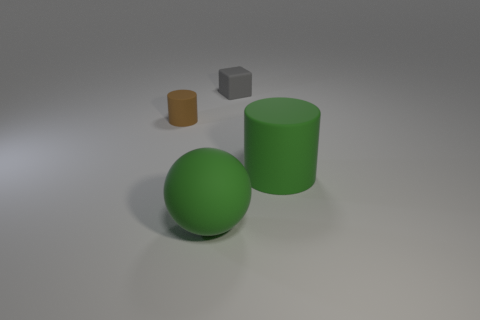What number of small brown rubber cylinders are in front of the large green object left of the small rubber object that is behind the small cylinder?
Offer a terse response. 0. There is a big green rubber sphere; are there any rubber cubes in front of it?
Your answer should be very brief. No. Are there any other things that have the same color as the small rubber cylinder?
Your response must be concise. No. How many cylinders are either gray rubber things or small brown objects?
Offer a terse response. 1. How many things are both in front of the small gray matte thing and to the left of the large green cylinder?
Provide a short and direct response. 2. Are there an equal number of things in front of the gray rubber thing and small brown things left of the green matte cylinder?
Your answer should be very brief. No. Is the shape of the large thing right of the tiny gray matte block the same as  the tiny brown thing?
Make the answer very short. Yes. What is the shape of the gray rubber object that is behind the large rubber thing that is right of the small rubber object behind the brown rubber cylinder?
Make the answer very short. Cube. What shape is the large thing that is the same color as the large rubber cylinder?
Offer a terse response. Sphere. The object that is on the left side of the rubber block and in front of the tiny cylinder is made of what material?
Your answer should be compact. Rubber. 